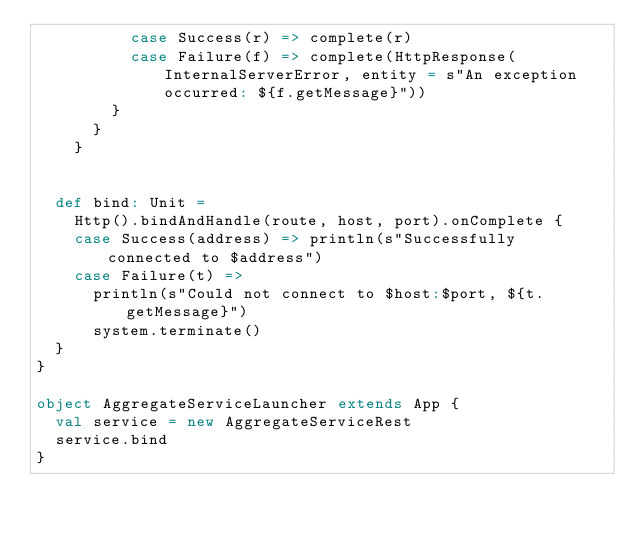Convert code to text. <code><loc_0><loc_0><loc_500><loc_500><_Scala_>          case Success(r) => complete(r)
          case Failure(f) => complete(HttpResponse(InternalServerError, entity = s"An exception occurred: ${f.getMessage}"))
        }
      }
    }


  def bind: Unit =
    Http().bindAndHandle(route, host, port).onComplete {
    case Success(address) => println(s"Successfully connected to $address")
    case Failure(t) =>
      println(s"Could not connect to $host:$port, ${t.getMessage}")
      system.terminate()
  }
}

object AggregateServiceLauncher extends App {
  val service = new AggregateServiceRest
  service.bind
}</code> 